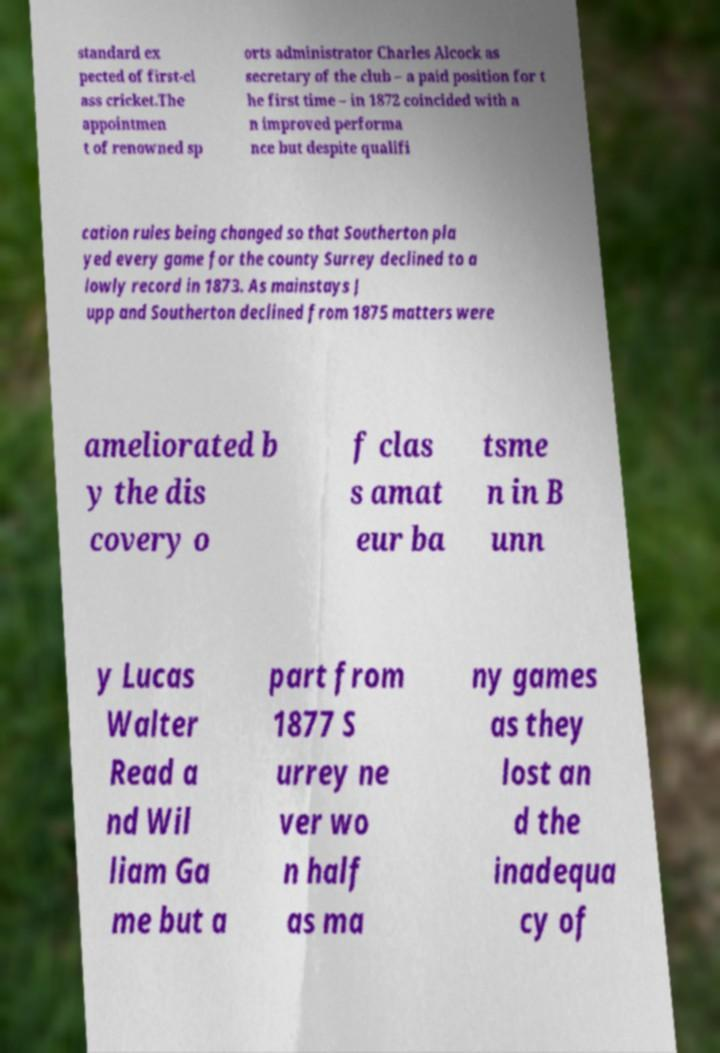Can you accurately transcribe the text from the provided image for me? standard ex pected of first-cl ass cricket.The appointmen t of renowned sp orts administrator Charles Alcock as secretary of the club – a paid position for t he first time – in 1872 coincided with a n improved performa nce but despite qualifi cation rules being changed so that Southerton pla yed every game for the county Surrey declined to a lowly record in 1873. As mainstays J upp and Southerton declined from 1875 matters were ameliorated b y the dis covery o f clas s amat eur ba tsme n in B unn y Lucas Walter Read a nd Wil liam Ga me but a part from 1877 S urrey ne ver wo n half as ma ny games as they lost an d the inadequa cy of 